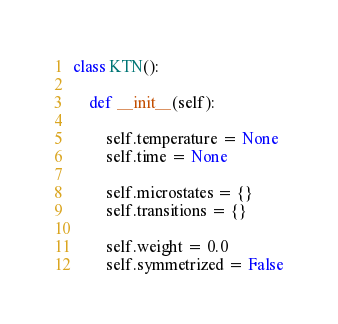<code> <loc_0><loc_0><loc_500><loc_500><_Python_>class KTN():

    def __init__(self):

        self.temperature = None
        self.time = None

        self.microstates = {}
        self.transitions = {}

        self.weight = 0.0
        self.symmetrized = False

</code> 